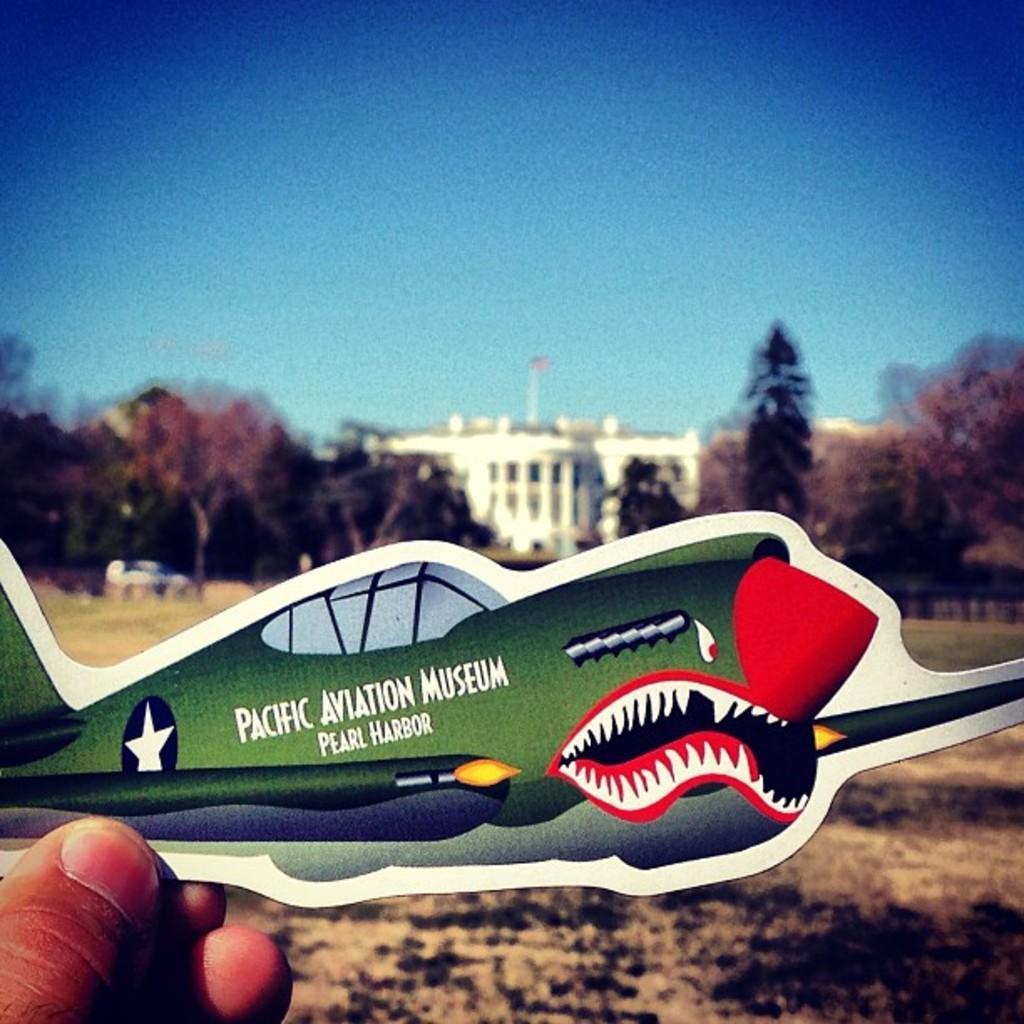How would you summarize this image in a sentence or two? In this picture I can see trees and a building and I can see a human hand holding a sticker of a plane and I can see a cloudy sky and looks like a car parked. 